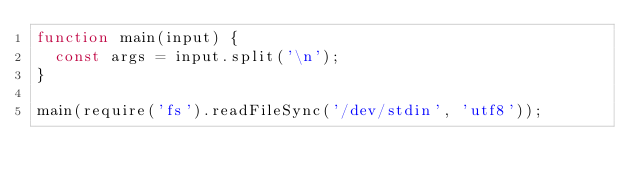Convert code to text. <code><loc_0><loc_0><loc_500><loc_500><_JavaScript_>function main(input) {
  const args = input.split('\n');
}

main(require('fs').readFileSync('/dev/stdin', 'utf8'));
</code> 